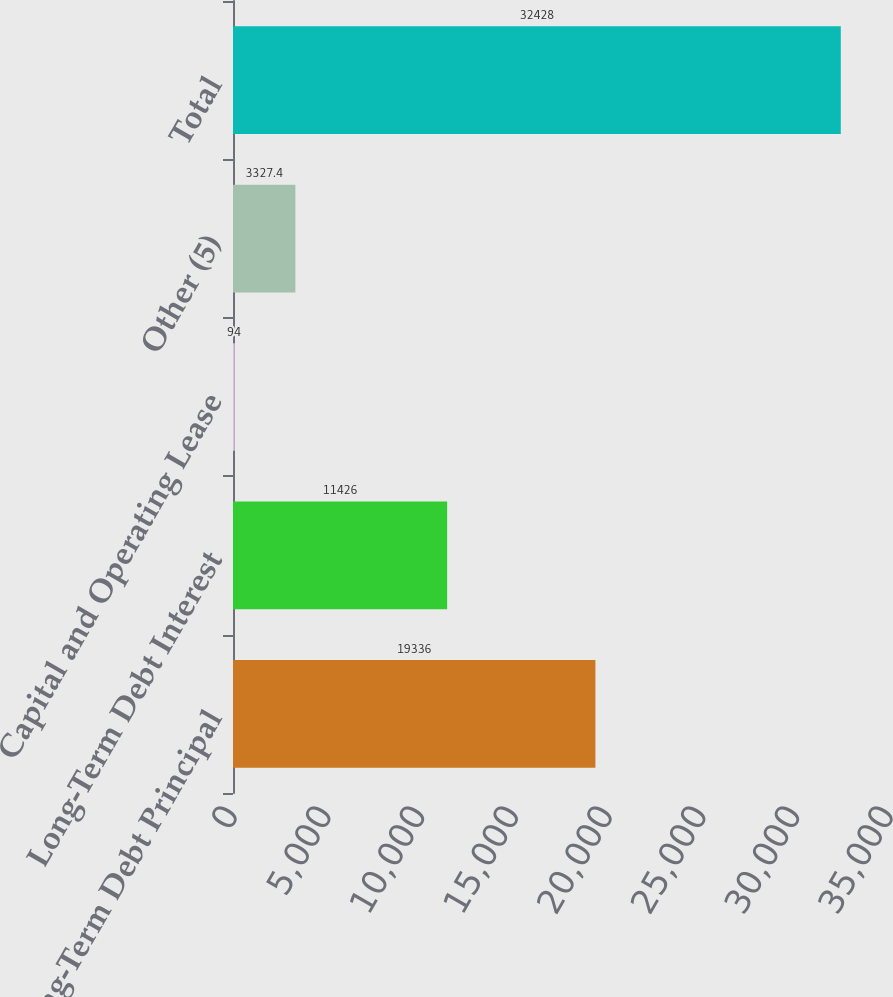Convert chart to OTSL. <chart><loc_0><loc_0><loc_500><loc_500><bar_chart><fcel>Long-Term Debt Principal<fcel>Long-Term Debt Interest<fcel>Capital and Operating Lease<fcel>Other (5)<fcel>Total<nl><fcel>19336<fcel>11426<fcel>94<fcel>3327.4<fcel>32428<nl></chart> 